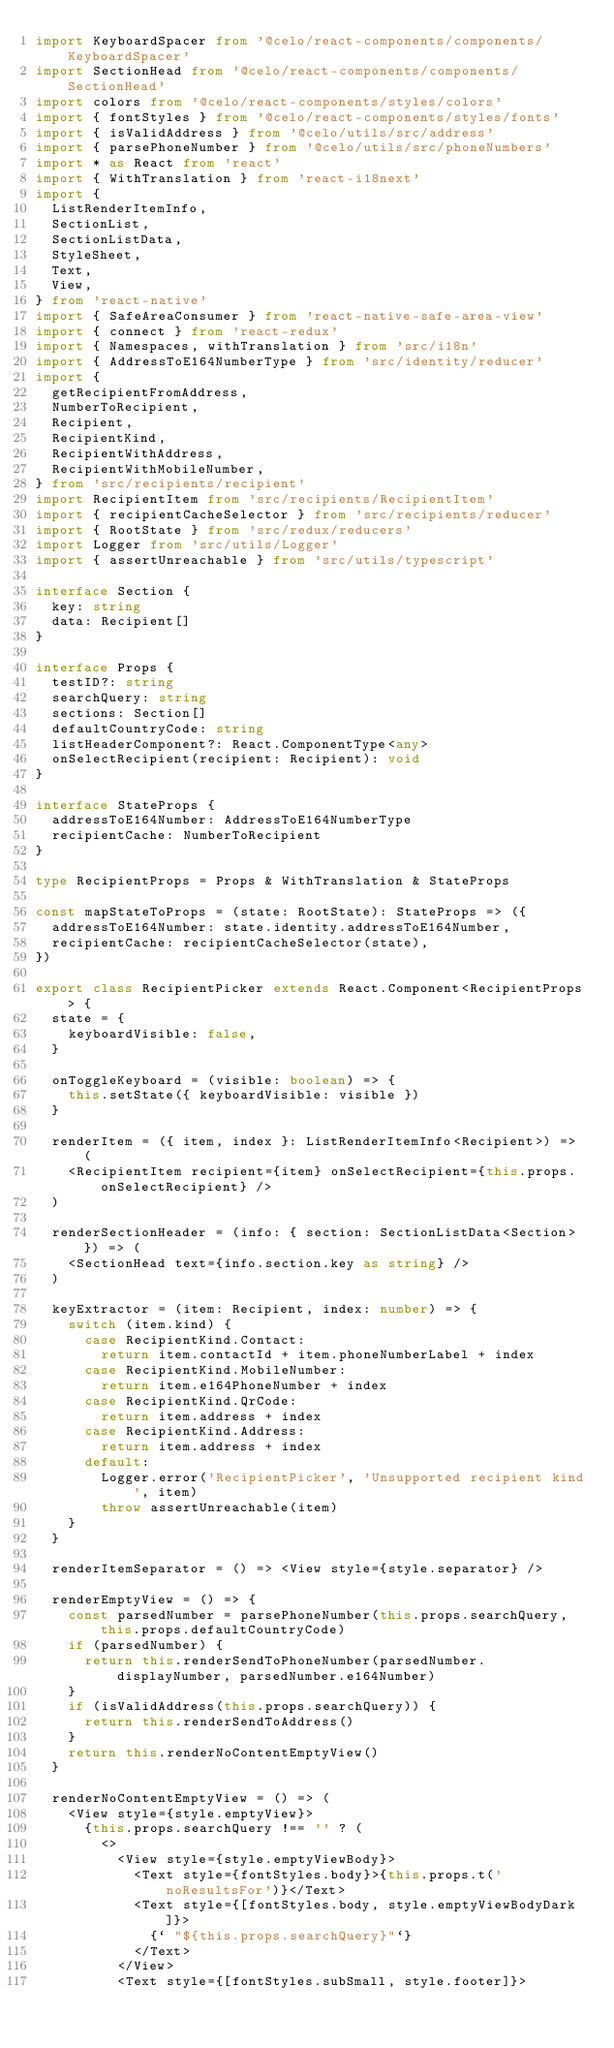<code> <loc_0><loc_0><loc_500><loc_500><_TypeScript_>import KeyboardSpacer from '@celo/react-components/components/KeyboardSpacer'
import SectionHead from '@celo/react-components/components/SectionHead'
import colors from '@celo/react-components/styles/colors'
import { fontStyles } from '@celo/react-components/styles/fonts'
import { isValidAddress } from '@celo/utils/src/address'
import { parsePhoneNumber } from '@celo/utils/src/phoneNumbers'
import * as React from 'react'
import { WithTranslation } from 'react-i18next'
import {
  ListRenderItemInfo,
  SectionList,
  SectionListData,
  StyleSheet,
  Text,
  View,
} from 'react-native'
import { SafeAreaConsumer } from 'react-native-safe-area-view'
import { connect } from 'react-redux'
import { Namespaces, withTranslation } from 'src/i18n'
import { AddressToE164NumberType } from 'src/identity/reducer'
import {
  getRecipientFromAddress,
  NumberToRecipient,
  Recipient,
  RecipientKind,
  RecipientWithAddress,
  RecipientWithMobileNumber,
} from 'src/recipients/recipient'
import RecipientItem from 'src/recipients/RecipientItem'
import { recipientCacheSelector } from 'src/recipients/reducer'
import { RootState } from 'src/redux/reducers'
import Logger from 'src/utils/Logger'
import { assertUnreachable } from 'src/utils/typescript'

interface Section {
  key: string
  data: Recipient[]
}

interface Props {
  testID?: string
  searchQuery: string
  sections: Section[]
  defaultCountryCode: string
  listHeaderComponent?: React.ComponentType<any>
  onSelectRecipient(recipient: Recipient): void
}

interface StateProps {
  addressToE164Number: AddressToE164NumberType
  recipientCache: NumberToRecipient
}

type RecipientProps = Props & WithTranslation & StateProps

const mapStateToProps = (state: RootState): StateProps => ({
  addressToE164Number: state.identity.addressToE164Number,
  recipientCache: recipientCacheSelector(state),
})

export class RecipientPicker extends React.Component<RecipientProps> {
  state = {
    keyboardVisible: false,
  }

  onToggleKeyboard = (visible: boolean) => {
    this.setState({ keyboardVisible: visible })
  }

  renderItem = ({ item, index }: ListRenderItemInfo<Recipient>) => (
    <RecipientItem recipient={item} onSelectRecipient={this.props.onSelectRecipient} />
  )

  renderSectionHeader = (info: { section: SectionListData<Section> }) => (
    <SectionHead text={info.section.key as string} />
  )

  keyExtractor = (item: Recipient, index: number) => {
    switch (item.kind) {
      case RecipientKind.Contact:
        return item.contactId + item.phoneNumberLabel + index
      case RecipientKind.MobileNumber:
        return item.e164PhoneNumber + index
      case RecipientKind.QrCode:
        return item.address + index
      case RecipientKind.Address:
        return item.address + index
      default:
        Logger.error('RecipientPicker', 'Unsupported recipient kind', item)
        throw assertUnreachable(item)
    }
  }

  renderItemSeparator = () => <View style={style.separator} />

  renderEmptyView = () => {
    const parsedNumber = parsePhoneNumber(this.props.searchQuery, this.props.defaultCountryCode)
    if (parsedNumber) {
      return this.renderSendToPhoneNumber(parsedNumber.displayNumber, parsedNumber.e164Number)
    }
    if (isValidAddress(this.props.searchQuery)) {
      return this.renderSendToAddress()
    }
    return this.renderNoContentEmptyView()
  }

  renderNoContentEmptyView = () => (
    <View style={style.emptyView}>
      {this.props.searchQuery !== '' ? (
        <>
          <View style={style.emptyViewBody}>
            <Text style={fontStyles.body}>{this.props.t('noResultsFor')}</Text>
            <Text style={[fontStyles.body, style.emptyViewBodyDark]}>
              {` "${this.props.searchQuery}"`}
            </Text>
          </View>
          <Text style={[fontStyles.subSmall, style.footer]}></code> 